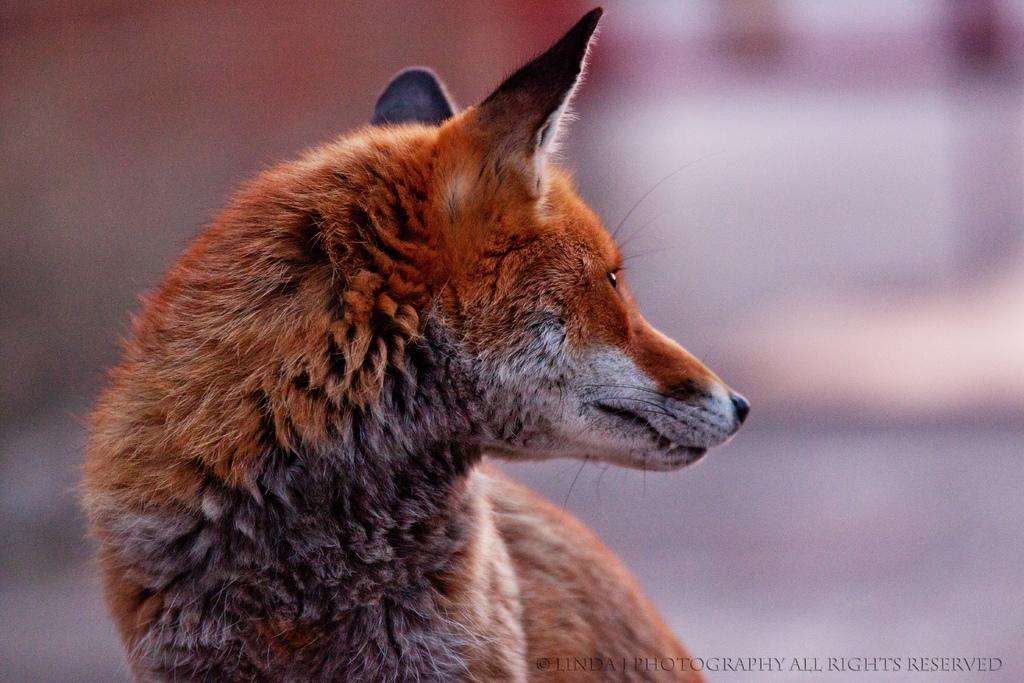What type of animal is in the image? There is a red fox in the image. Can you describe any additional features of the image? Yes, there is text written in the right bottom corner of the image. What decision is the fox making in the image? There is no indication in the image that the fox is making any decision. What type of fruit is the fox holding in the image? There is no fruit present in the image, and the fox is not holding anything. 